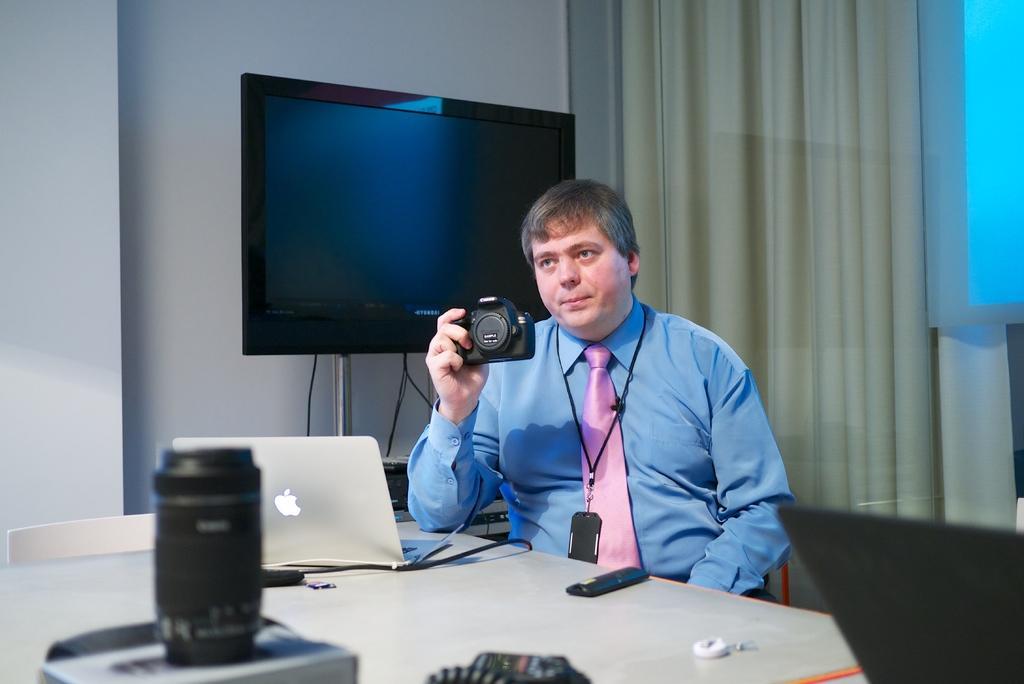Could you give a brief overview of what you see in this image? In this picture there is a man sitting holding the camera. In the foreground there is a laptop, remote and there are devices on the table. At the back there is a television, curtain and there might be a projector screen. 